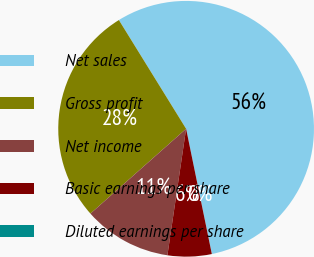Convert chart to OTSL. <chart><loc_0><loc_0><loc_500><loc_500><pie_chart><fcel>Net sales<fcel>Gross profit<fcel>Net income<fcel>Basic earnings per share<fcel>Diluted earnings per share<nl><fcel>55.59%<fcel>27.73%<fcel>11.12%<fcel>5.56%<fcel>0.0%<nl></chart> 